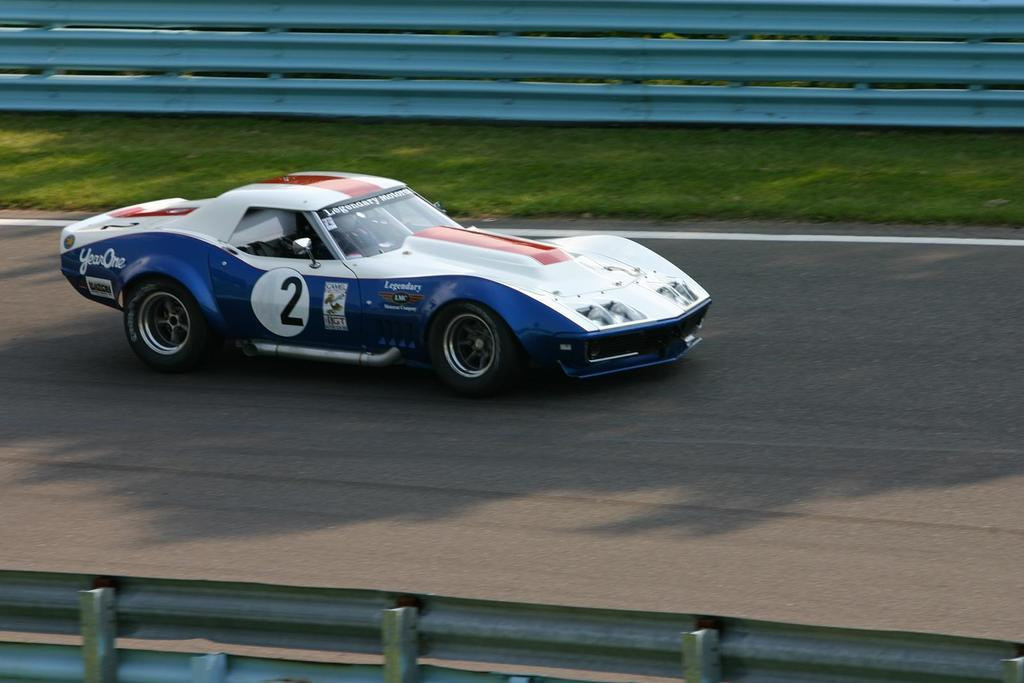What is the main subject of the image? There is a car on the road in the image. What type of vegetation can be seen in the image? There is grass visible in the image. What is the purpose of the barrier in the image? There is fencing in the image, which may serve as a barrier or boundary. How many drawers are visible in the image? There are no drawers present in the image. What type of planes can be seen flying in the image? There are no planes visible in the image. 